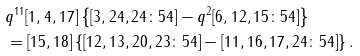<formula> <loc_0><loc_0><loc_500><loc_500>& q ^ { 1 1 } [ 1 , 4 , 1 7 ] \left \{ [ 3 , 2 4 , 2 4 \colon 5 4 ] - q ^ { 2 } [ 6 , 1 2 , 1 5 \colon 5 4 ] \right \} \\ & = [ 1 5 , 1 8 ] \left \{ [ 1 2 , 1 3 , 2 0 , 2 3 \colon 5 4 ] - [ 1 1 , 1 6 , 1 7 , 2 4 \colon 5 4 ] \right \} .</formula> 